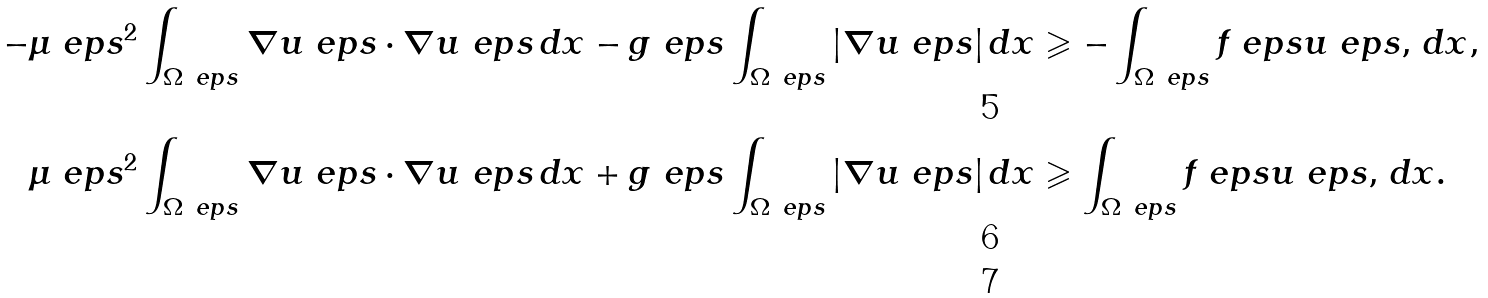Convert formula to latex. <formula><loc_0><loc_0><loc_500><loc_500>- \mu \ e p s ^ { 2 } \int _ { \Omega _ { \ } e p s } \nabla { u } _ { \ } e p s \cdot \nabla { u } _ { \ } e p s \, d { x } & - g \ e p s \int _ { \Omega _ { \ } e p s } | \nabla { u } _ { \ } e p s | \, d { x } \geqslant - \int _ { \Omega _ { \ } e p s } { f } _ { \ } e p s { u } _ { \ } e p s , \, d { x } , \\ \mu \ e p s ^ { 2 } \int _ { \Omega _ { \ } e p s } \nabla { u } _ { \ } e p s \cdot \nabla { u } _ { \ } e p s \, d { x } & + g \ e p s \int _ { \Omega _ { \ } e p s } | \nabla { u } _ { \ } e p s | \, d { x } \geqslant \int _ { \Omega _ { \ } e p s } { f } _ { \ } e p s { u } _ { \ } e p s , \, d { x } . \\</formula> 